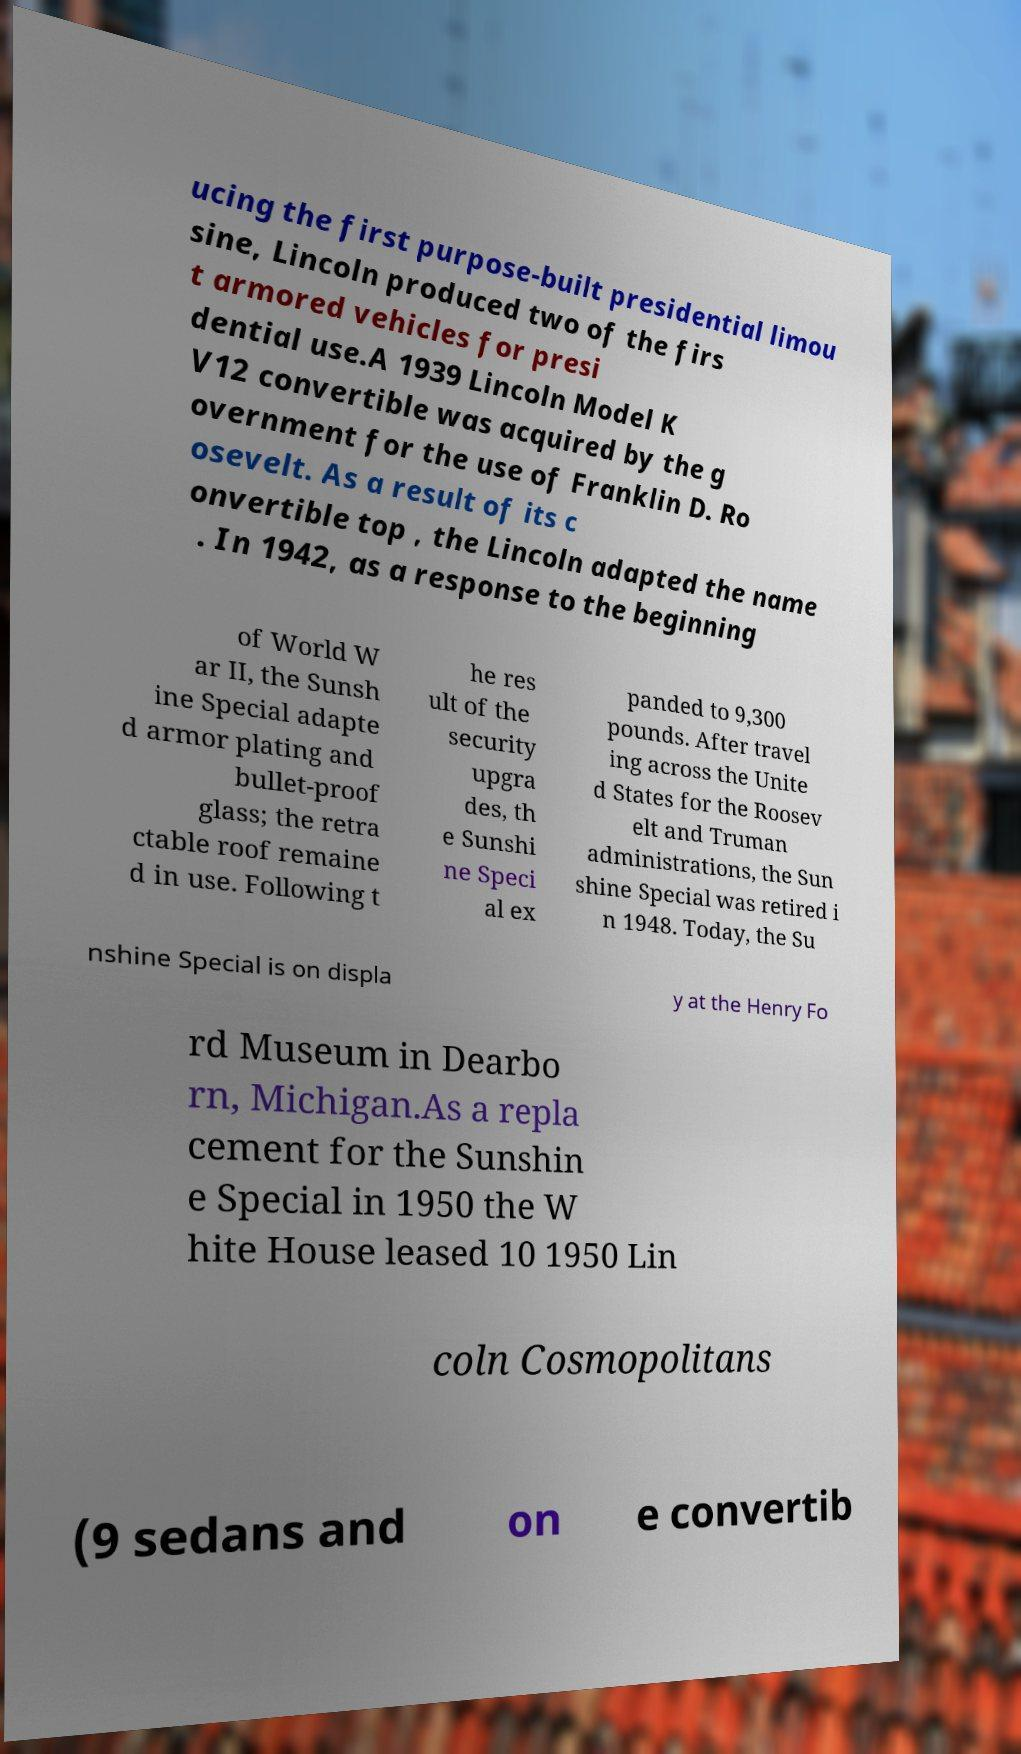Please identify and transcribe the text found in this image. ucing the first purpose-built presidential limou sine, Lincoln produced two of the firs t armored vehicles for presi dential use.A 1939 Lincoln Model K V12 convertible was acquired by the g overnment for the use of Franklin D. Ro osevelt. As a result of its c onvertible top , the Lincoln adapted the name . In 1942, as a response to the beginning of World W ar II, the Sunsh ine Special adapte d armor plating and bullet-proof glass; the retra ctable roof remaine d in use. Following t he res ult of the security upgra des, th e Sunshi ne Speci al ex panded to 9,300 pounds. After travel ing across the Unite d States for the Roosev elt and Truman administrations, the Sun shine Special was retired i n 1948. Today, the Su nshine Special is on displa y at the Henry Fo rd Museum in Dearbo rn, Michigan.As a repla cement for the Sunshin e Special in 1950 the W hite House leased 10 1950 Lin coln Cosmopolitans (9 sedans and on e convertib 